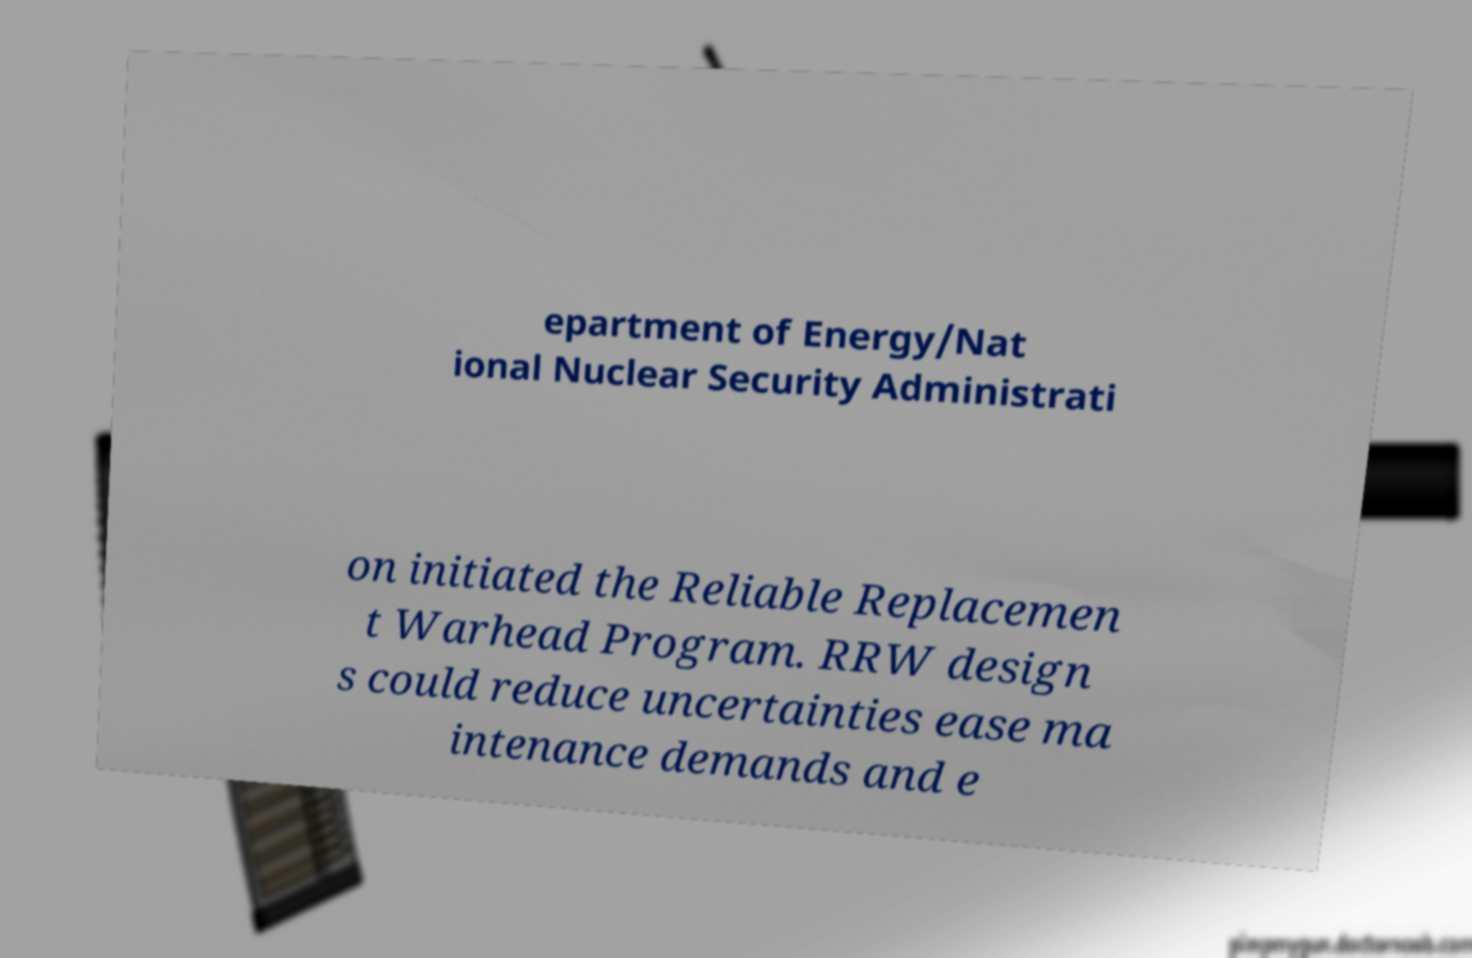Can you read and provide the text displayed in the image?This photo seems to have some interesting text. Can you extract and type it out for me? epartment of Energy/Nat ional Nuclear Security Administrati on initiated the Reliable Replacemen t Warhead Program. RRW design s could reduce uncertainties ease ma intenance demands and e 